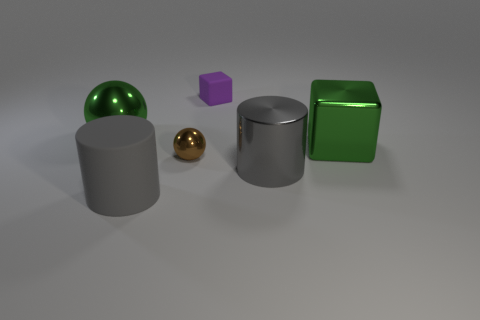Does the big cylinder that is right of the purple matte thing have the same material as the big green thing right of the brown shiny sphere?
Make the answer very short. Yes. Does the thing left of the gray rubber object have the same shape as the small shiny thing to the right of the gray rubber cylinder?
Ensure brevity in your answer.  Yes. Are there fewer small matte cubes that are in front of the small metallic sphere than gray metal objects?
Provide a succinct answer. Yes. What number of metal cylinders have the same color as the big sphere?
Your answer should be compact. 0. There is a shiny sphere that is left of the tiny brown thing; what is its size?
Your response must be concise. Large. What shape is the big green thing behind the large green thing that is on the right side of the big metallic thing behind the big green cube?
Make the answer very short. Sphere. There is a thing that is both to the left of the tiny sphere and behind the tiny brown metallic thing; what shape is it?
Give a very brief answer. Sphere. Are there any brown metal balls of the same size as the purple matte thing?
Offer a terse response. Yes. There is a big gray thing that is to the left of the metallic cylinder; does it have the same shape as the gray metallic thing?
Provide a succinct answer. Yes. Is the big gray matte thing the same shape as the big gray shiny thing?
Your answer should be very brief. Yes. 